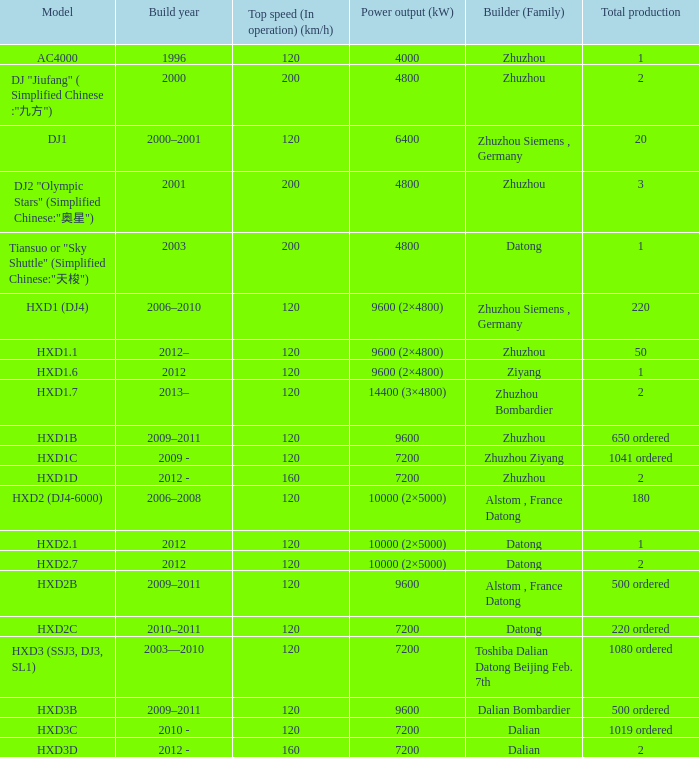What is the power output (kw) of builder zhuzhou, model hxd1d, with a total production of 2? 7200.0. 